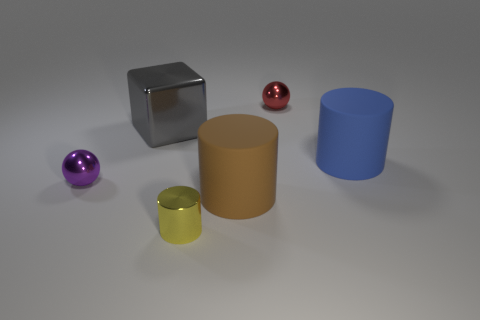Can you tell me what time of day the lighting suggests in this scene? The lighting in this scene appears to be neutral, resembling a studio setting with controlled light sources rather than natural sunlight. There are no indications of a specific time of day. 